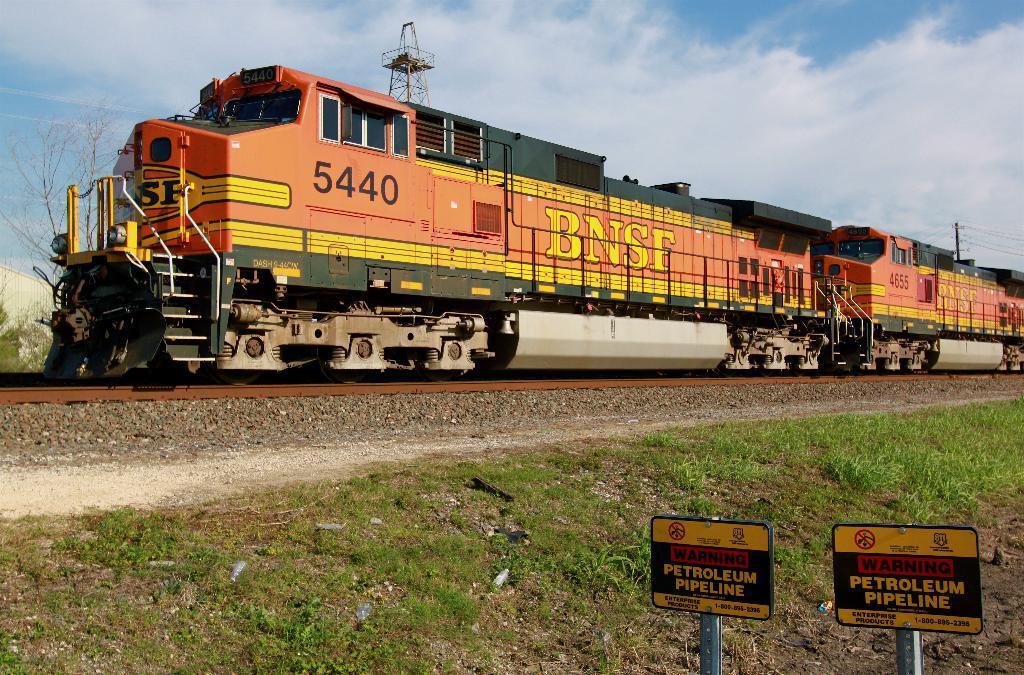Please provide a concise description of this image. In this image, we can see a train on the track. At the bottom, we can see grass, ground, name boards and poles. Background we can see the cloudy sky, tower, pole and wires. Left side of the image, we can see trees and wall. 